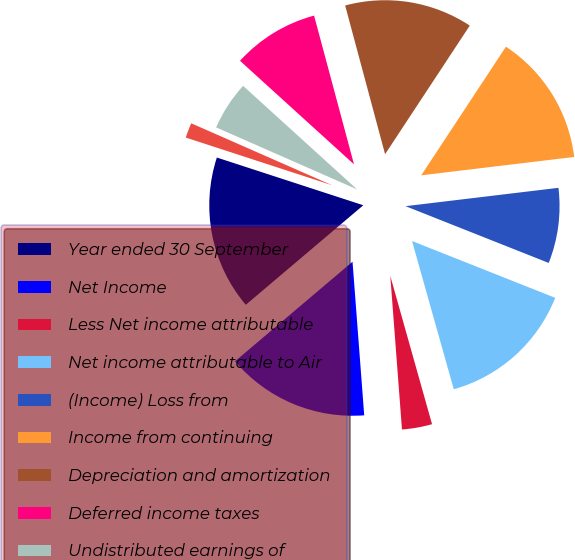Convert chart. <chart><loc_0><loc_0><loc_500><loc_500><pie_chart><fcel>Year ended 30 September<fcel>Net Income<fcel>Less Net income attributable<fcel>Net income attributable to Air<fcel>(Income) Loss from<fcel>Income from continuing<fcel>Depreciation and amortization<fcel>Deferred income taxes<fcel>Undistributed earnings of<fcel>Gain on sale of assets and<nl><fcel>16.2%<fcel>15.02%<fcel>3.16%<fcel>14.62%<fcel>7.91%<fcel>13.83%<fcel>13.44%<fcel>9.09%<fcel>5.14%<fcel>1.58%<nl></chart> 